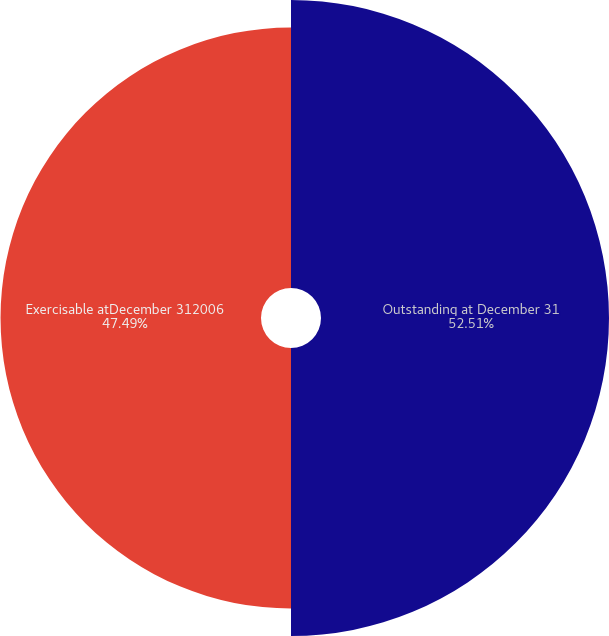Convert chart. <chart><loc_0><loc_0><loc_500><loc_500><pie_chart><fcel>Outstanding at December 31<fcel>Exercisable atDecember 312006<nl><fcel>52.51%<fcel>47.49%<nl></chart> 